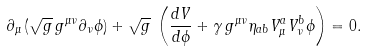Convert formula to latex. <formula><loc_0><loc_0><loc_500><loc_500>\partial _ { \mu } \left ( \sqrt { g } \, g ^ { \mu \nu } \partial _ { \nu } \phi \right ) + \sqrt { g } \, \left ( \frac { d V } { d \phi } + \gamma \, g ^ { \mu \nu } \eta _ { a b } V ^ { a } _ { \mu } V ^ { b } _ { \nu } \phi \right ) = 0 .</formula> 